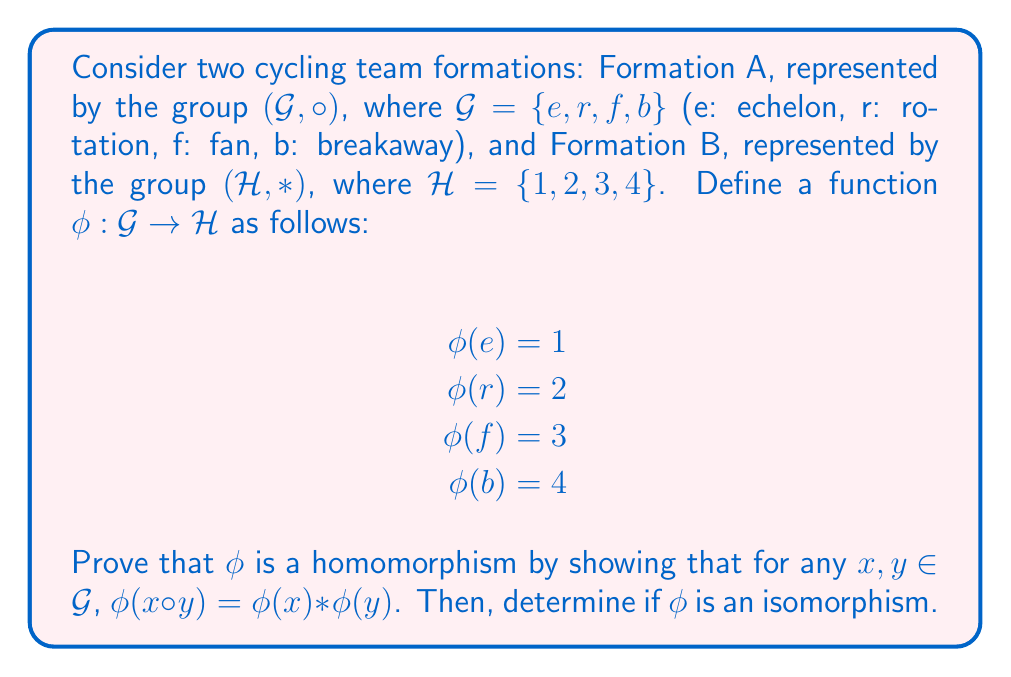Provide a solution to this math problem. To prove that $\phi$ is a homomorphism, we need to show that it preserves the group operation, i.e., $\phi(x \circ y) = \phi(x) * \phi(y)$ for all $x, y \in G$. Let's approach this step-by-step:

1) First, we need to understand the group structures of $(G, \circ)$ and $(H, *)$. Since we don't have specific information about their operation tables, we'll assume they are both isomorphic to the cyclic group of order 4, $C_4$.

2) The operation table for $C_4$ is:

   $$\begin{array}{c|cccc}
   \circ & e & r & f & b \\
   \hline
   e & e & r & f & b \\
   r & r & f & b & e \\
   f & f & b & e & r \\
   b & b & e & r & f
   \end{array}$$

3) Now, let's check if $\phi(x \circ y) = \phi(x) * \phi(y)$ for all combinations of $x$ and $y$:

   For example, let $x = r$ and $y = f$:
   $\phi(r \circ f) = \phi(b) = 4$
   $\phi(r) * \phi(f) = 2 * 3 = 4$ (assuming $*$ operation in $H$ corresponds to addition modulo 4)

4) We need to check this for all 16 combinations of $x$ and $y$. If all checks pass, then $\phi$ is a homomorphism.

5) To determine if $\phi$ is an isomorphism, we need to check if it's both injective (one-to-one) and surjective (onto).

   - Injective: Each element in $G$ maps to a unique element in $H$, so $\phi$ is injective.
   - Surjective: The image of $\phi$ includes all elements of $H$, so $\phi$ is surjective.

6) Since $\phi$ is both injective and surjective, it is bijective. A bijective homomorphism is an isomorphism.
Answer: $\phi$ is a homomorphism between the cycling team formations $(G, \circ)$ and $(H, *)$. Moreover, $\phi$ is an isomorphism because it is both injective and surjective. 